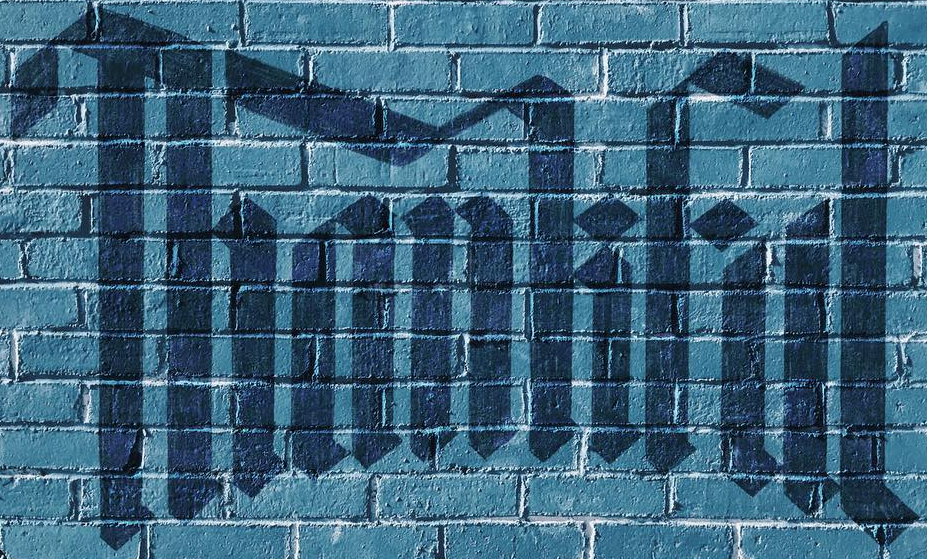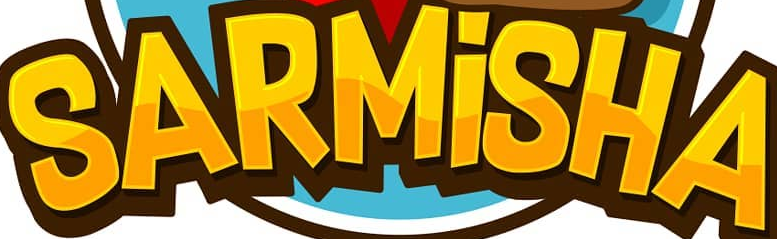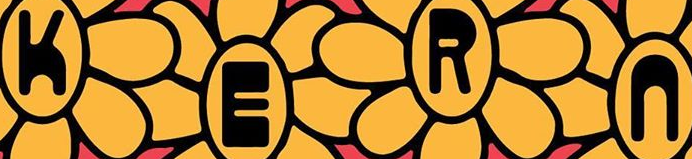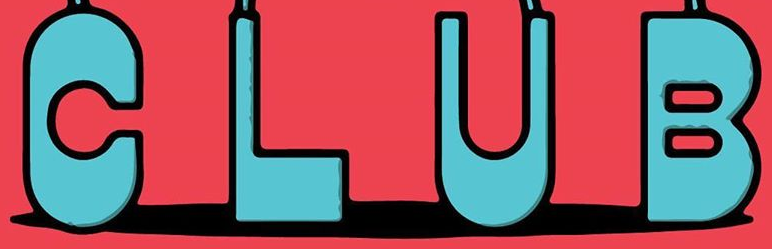What words are shown in these images in order, separated by a semicolon? Thankful; SARMİSHA; KERn; CLUB 